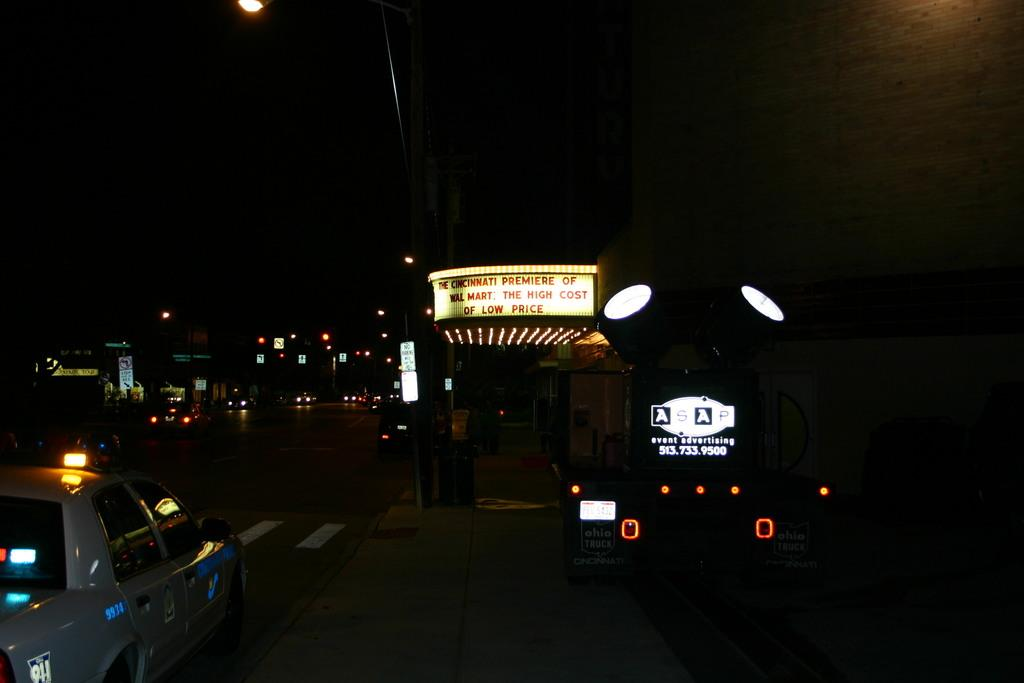Provide a one-sentence caption for the provided image. A Cincinnati premier is advertised on a large, lit sign. 